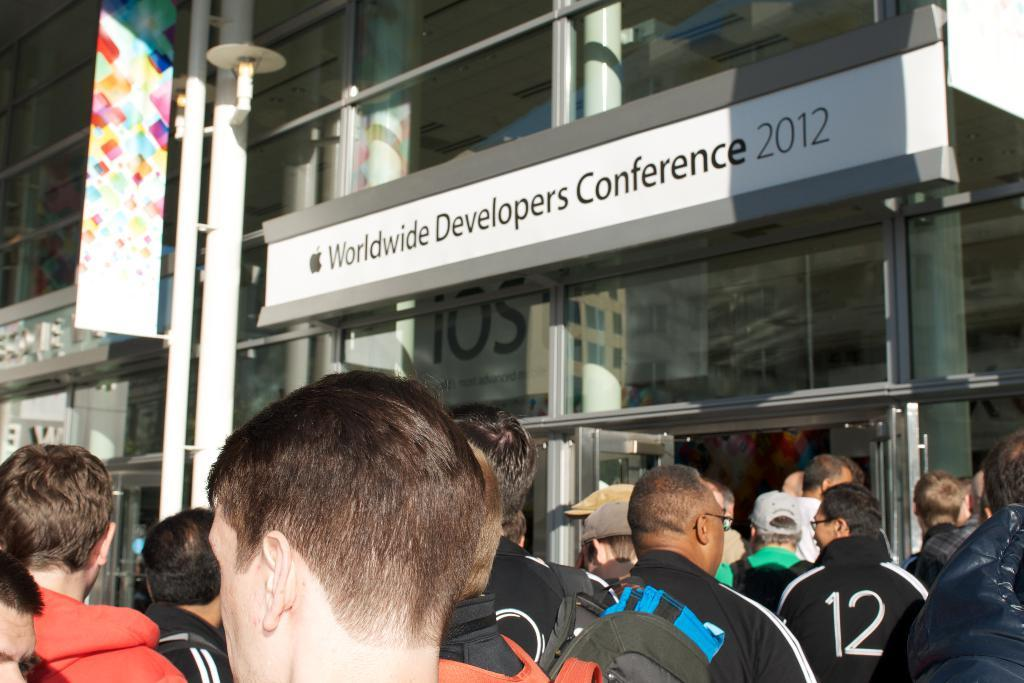What are the people in the image doing? There are people walking into a store in the image. What can be seen in the background of the image? There is a banner on a pole, boards, and a glass building visible in the background of the image. What type of sail can be seen on the vase in the image? There is no vase or sail present in the image. 